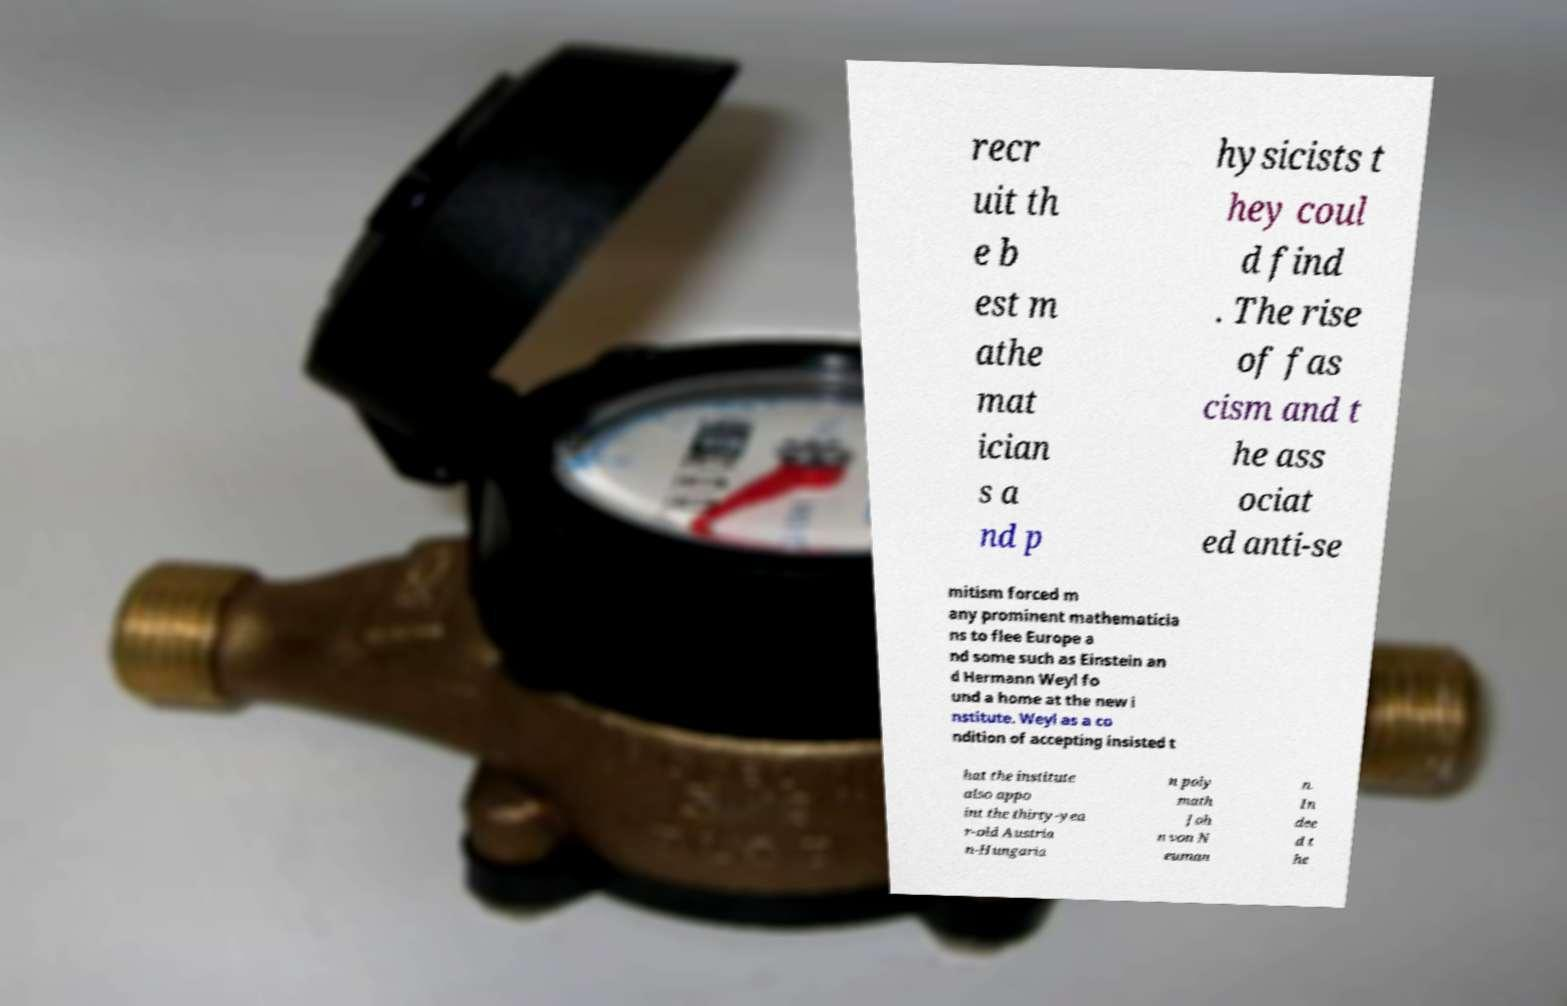Could you assist in decoding the text presented in this image and type it out clearly? recr uit th e b est m athe mat ician s a nd p hysicists t hey coul d find . The rise of fas cism and t he ass ociat ed anti-se mitism forced m any prominent mathematicia ns to flee Europe a nd some such as Einstein an d Hermann Weyl fo und a home at the new i nstitute. Weyl as a co ndition of accepting insisted t hat the institute also appo int the thirty-yea r-old Austria n-Hungaria n poly math Joh n von N euman n. In dee d t he 